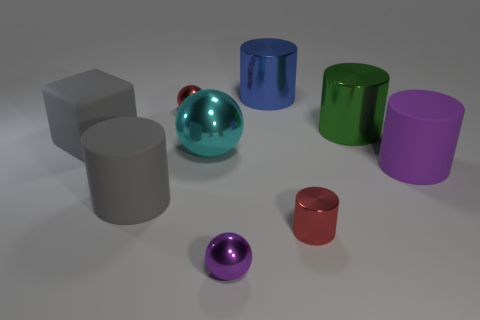Are there any small red metallic objects of the same shape as the big blue thing?
Provide a short and direct response. Yes. The blue object that is the same size as the green metal object is what shape?
Your response must be concise. Cylinder. What is the tiny cylinder made of?
Provide a succinct answer. Metal. There is a rubber cylinder behind the big rubber cylinder that is left of the small red shiny thing behind the large purple cylinder; what is its size?
Provide a short and direct response. Large. There is a thing that is the same color as the matte block; what is it made of?
Offer a very short reply. Rubber. How many metallic objects are either things or big blue things?
Provide a short and direct response. 6. How big is the green metallic object?
Provide a short and direct response. Large. What number of things are either big green cylinders or matte objects that are right of the small purple sphere?
Keep it short and to the point. 2. How many other objects are the same color as the large cube?
Your response must be concise. 1. Do the purple cylinder and the purple metallic sphere on the right side of the red sphere have the same size?
Keep it short and to the point. No. 